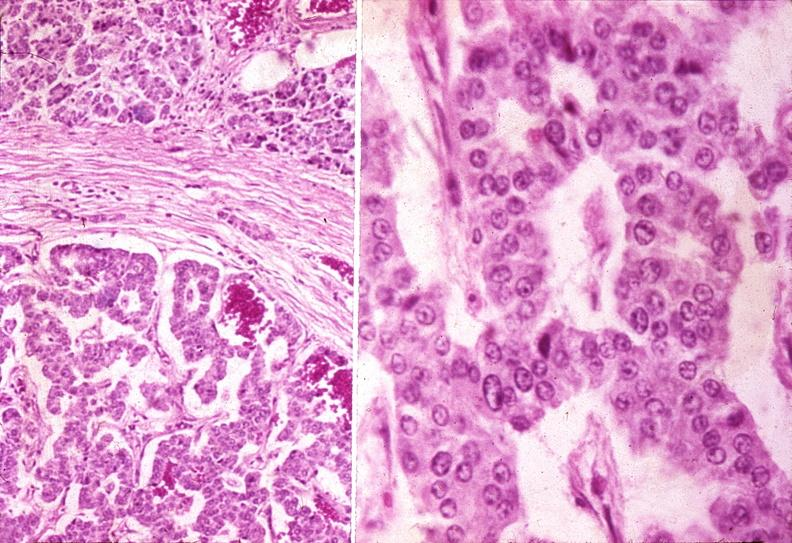does cytomegaly show islet cell carcinoma?
Answer the question using a single word or phrase. No 